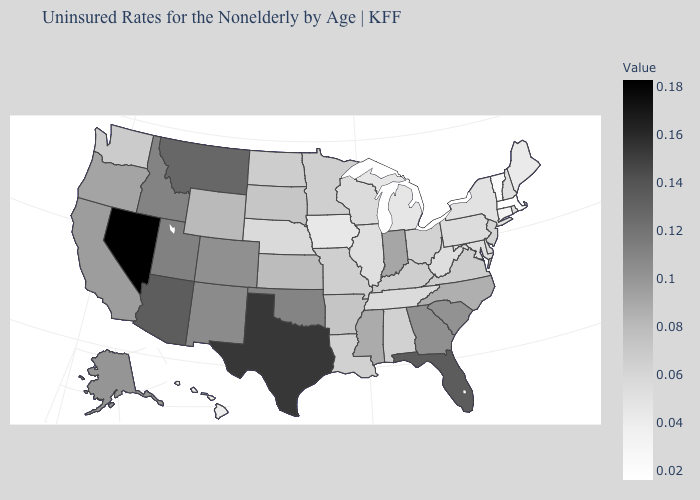Is the legend a continuous bar?
Keep it brief. Yes. Does Nebraska have a lower value than Indiana?
Keep it brief. Yes. 